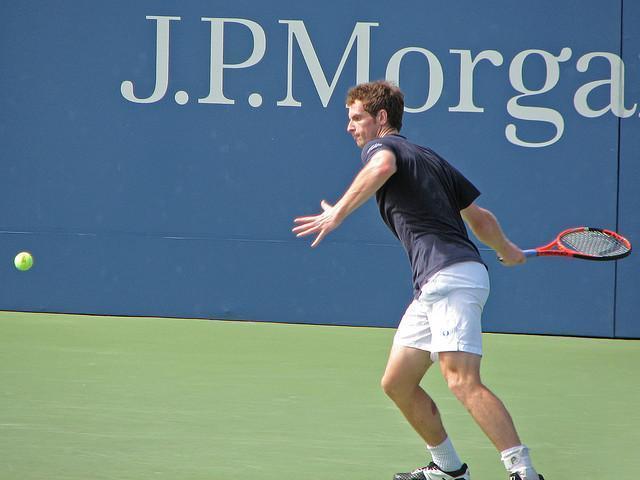How many people are in the picture?
Give a very brief answer. 1. How many knives to the left?
Give a very brief answer. 0. 